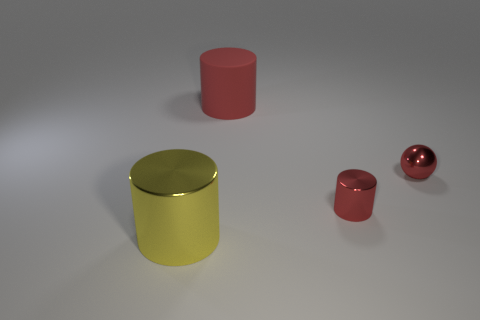How many red cylinders must be subtracted to get 1 red cylinders? 1 Add 1 matte cylinders. How many objects exist? 5 Subtract all spheres. How many objects are left? 3 Subtract all yellow cylinders. Subtract all yellow objects. How many objects are left? 2 Add 1 large cylinders. How many large cylinders are left? 3 Add 1 metal spheres. How many metal spheres exist? 2 Subtract 0 gray cylinders. How many objects are left? 4 